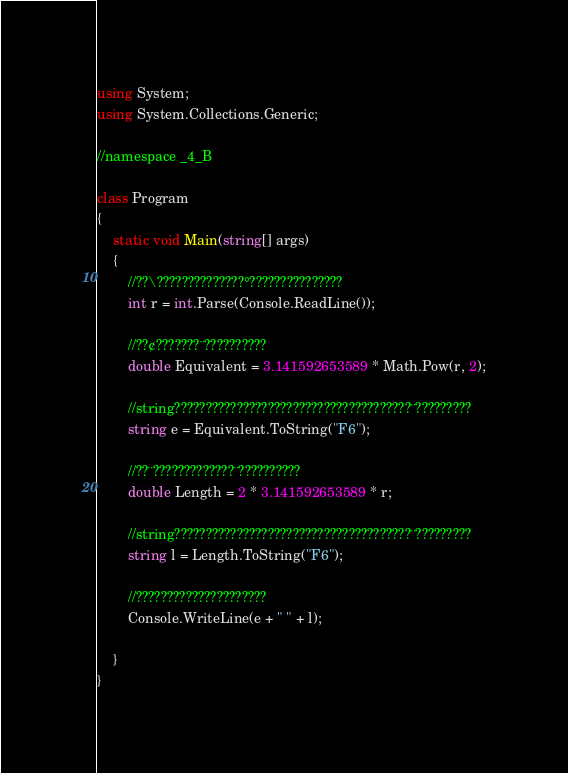<code> <loc_0><loc_0><loc_500><loc_500><_C#_>using System;
using System.Collections.Generic;

//namespace _4_B

class Program
{
    static void Main(string[] args)
    {
        //??\??????????????°???????????????
        int r = int.Parse(Console.ReadLine());

        //??¢???????¨??????????
        double Equivalent = 3.141592653589 * Math.Pow(r, 2);

        //string??????????????????????????????????????¨?????????
        string e = Equivalent.ToString("F6");

        //??¨?????????????¨??????????
        double Length = 2 * 3.141592653589 * r;

        //string??????????????????????????????????????¨?????????
        string l = Length.ToString("F6");

        //?????????????????????
        Console.WriteLine(e + " " + l);

    }
}</code> 